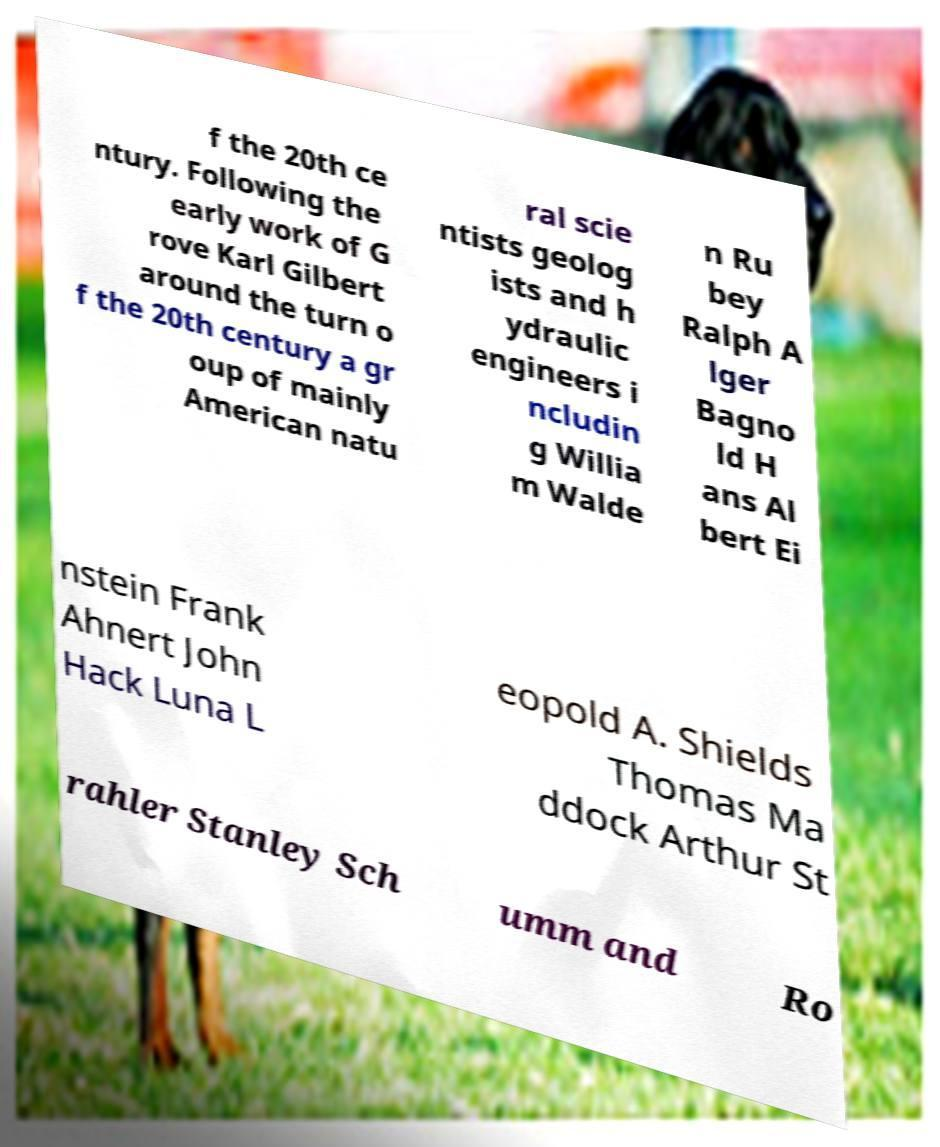Can you accurately transcribe the text from the provided image for me? f the 20th ce ntury. Following the early work of G rove Karl Gilbert around the turn o f the 20th century a gr oup of mainly American natu ral scie ntists geolog ists and h ydraulic engineers i ncludin g Willia m Walde n Ru bey Ralph A lger Bagno ld H ans Al bert Ei nstein Frank Ahnert John Hack Luna L eopold A. Shields Thomas Ma ddock Arthur St rahler Stanley Sch umm and Ro 